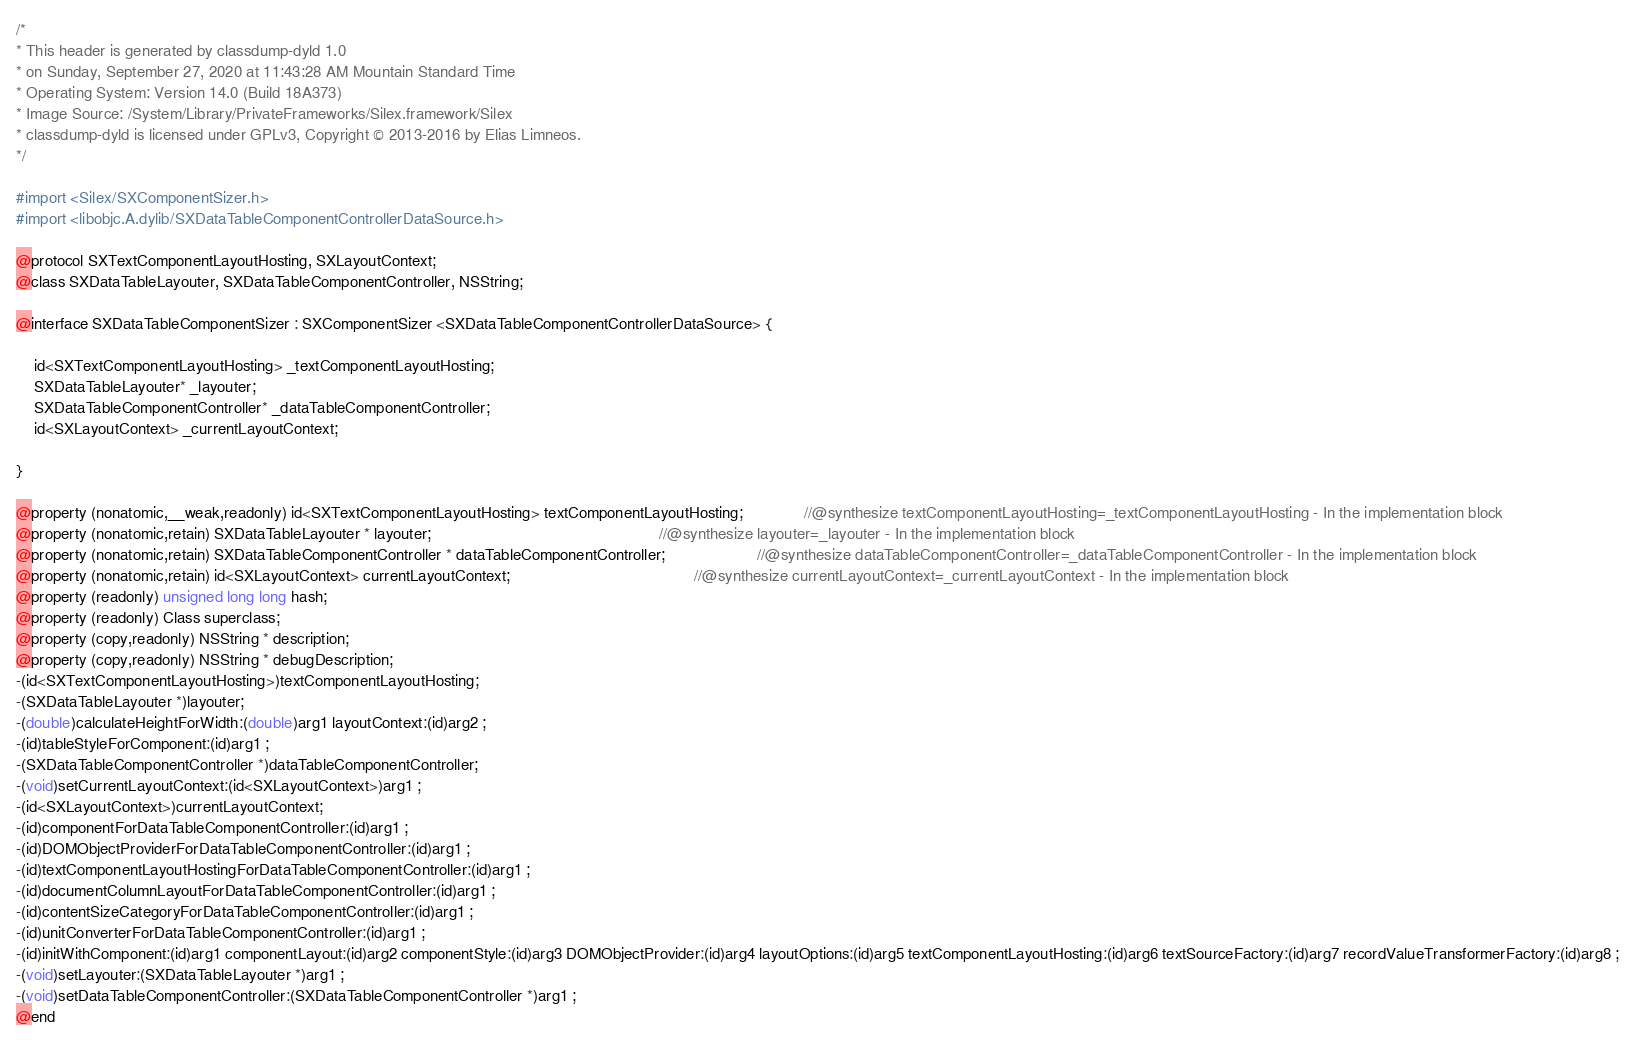<code> <loc_0><loc_0><loc_500><loc_500><_C_>/*
* This header is generated by classdump-dyld 1.0
* on Sunday, September 27, 2020 at 11:43:28 AM Mountain Standard Time
* Operating System: Version 14.0 (Build 18A373)
* Image Source: /System/Library/PrivateFrameworks/Silex.framework/Silex
* classdump-dyld is licensed under GPLv3, Copyright © 2013-2016 by Elias Limneos.
*/

#import <Silex/SXComponentSizer.h>
#import <libobjc.A.dylib/SXDataTableComponentControllerDataSource.h>

@protocol SXTextComponentLayoutHosting, SXLayoutContext;
@class SXDataTableLayouter, SXDataTableComponentController, NSString;

@interface SXDataTableComponentSizer : SXComponentSizer <SXDataTableComponentControllerDataSource> {

	id<SXTextComponentLayoutHosting> _textComponentLayoutHosting;
	SXDataTableLayouter* _layouter;
	SXDataTableComponentController* _dataTableComponentController;
	id<SXLayoutContext> _currentLayoutContext;

}

@property (nonatomic,__weak,readonly) id<SXTextComponentLayoutHosting> textComponentLayoutHosting;              //@synthesize textComponentLayoutHosting=_textComponentLayoutHosting - In the implementation block
@property (nonatomic,retain) SXDataTableLayouter * layouter;                                                    //@synthesize layouter=_layouter - In the implementation block
@property (nonatomic,retain) SXDataTableComponentController * dataTableComponentController;                     //@synthesize dataTableComponentController=_dataTableComponentController - In the implementation block
@property (nonatomic,retain) id<SXLayoutContext> currentLayoutContext;                                          //@synthesize currentLayoutContext=_currentLayoutContext - In the implementation block
@property (readonly) unsigned long long hash; 
@property (readonly) Class superclass; 
@property (copy,readonly) NSString * description; 
@property (copy,readonly) NSString * debugDescription; 
-(id<SXTextComponentLayoutHosting>)textComponentLayoutHosting;
-(SXDataTableLayouter *)layouter;
-(double)calculateHeightForWidth:(double)arg1 layoutContext:(id)arg2 ;
-(id)tableStyleForComponent:(id)arg1 ;
-(SXDataTableComponentController *)dataTableComponentController;
-(void)setCurrentLayoutContext:(id<SXLayoutContext>)arg1 ;
-(id<SXLayoutContext>)currentLayoutContext;
-(id)componentForDataTableComponentController:(id)arg1 ;
-(id)DOMObjectProviderForDataTableComponentController:(id)arg1 ;
-(id)textComponentLayoutHostingForDataTableComponentController:(id)arg1 ;
-(id)documentColumnLayoutForDataTableComponentController:(id)arg1 ;
-(id)contentSizeCategoryForDataTableComponentController:(id)arg1 ;
-(id)unitConverterForDataTableComponentController:(id)arg1 ;
-(id)initWithComponent:(id)arg1 componentLayout:(id)arg2 componentStyle:(id)arg3 DOMObjectProvider:(id)arg4 layoutOptions:(id)arg5 textComponentLayoutHosting:(id)arg6 textSourceFactory:(id)arg7 recordValueTransformerFactory:(id)arg8 ;
-(void)setLayouter:(SXDataTableLayouter *)arg1 ;
-(void)setDataTableComponentController:(SXDataTableComponentController *)arg1 ;
@end

</code> 